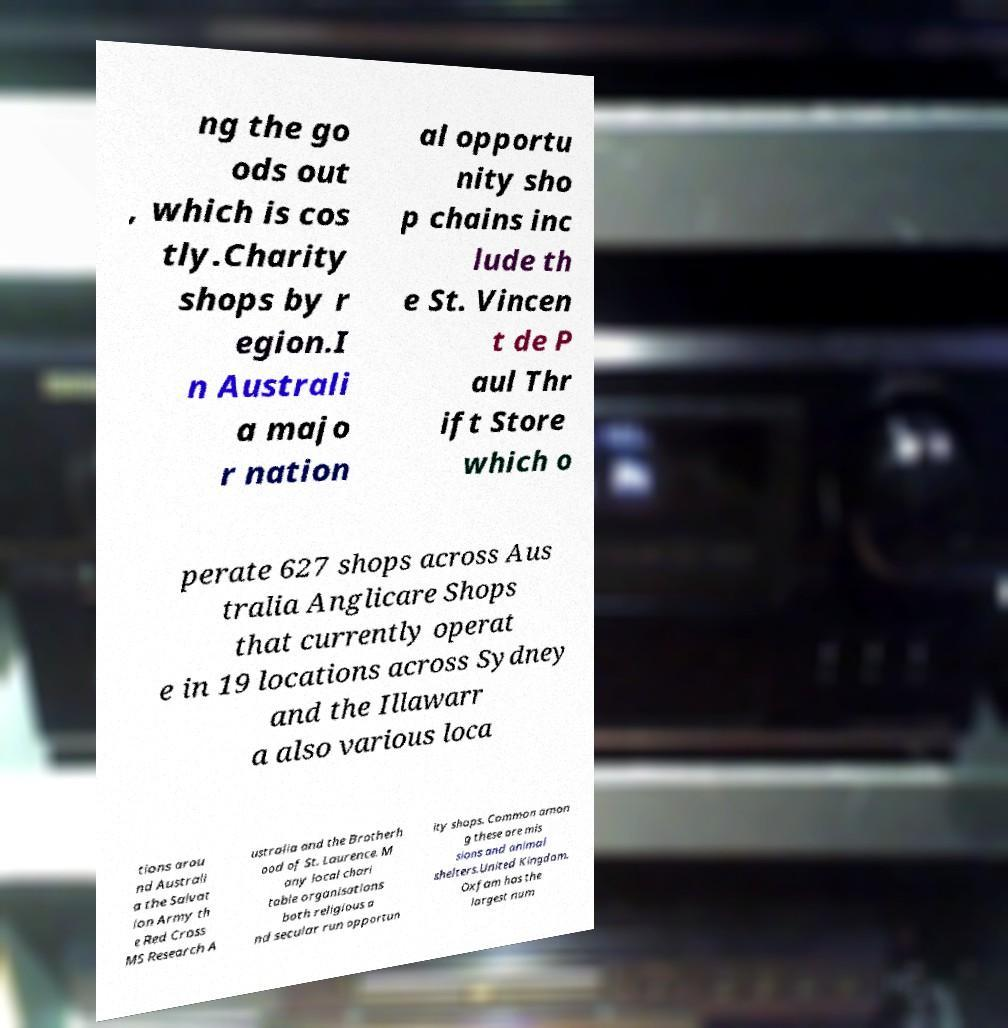Please read and relay the text visible in this image. What does it say? ng the go ods out , which is cos tly.Charity shops by r egion.I n Australi a majo r nation al opportu nity sho p chains inc lude th e St. Vincen t de P aul Thr ift Store which o perate 627 shops across Aus tralia Anglicare Shops that currently operat e in 19 locations across Sydney and the Illawarr a also various loca tions arou nd Australi a the Salvat ion Army th e Red Cross MS Research A ustralia and the Brotherh ood of St. Laurence. M any local chari table organisations both religious a nd secular run opportun ity shops. Common amon g these are mis sions and animal shelters.United Kingdom. Oxfam has the largest num 